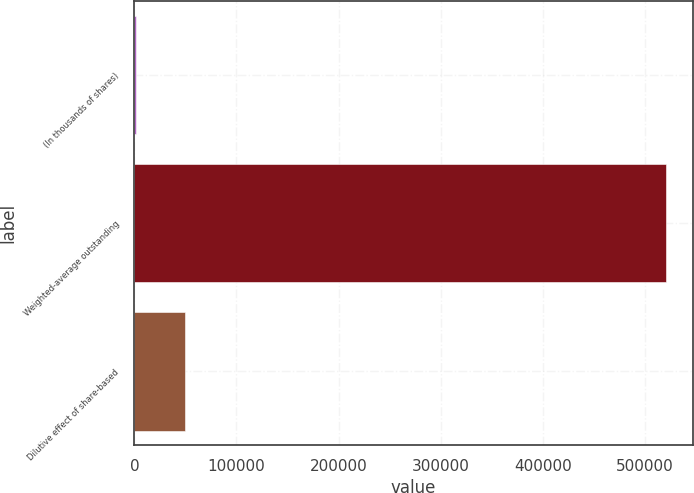Convert chart. <chart><loc_0><loc_0><loc_500><loc_500><bar_chart><fcel>(In thousands of shares)<fcel>Weighted-average outstanding<fcel>Dilutive effect of share-based<nl><fcel>2008<fcel>521086<fcel>49688.7<nl></chart> 